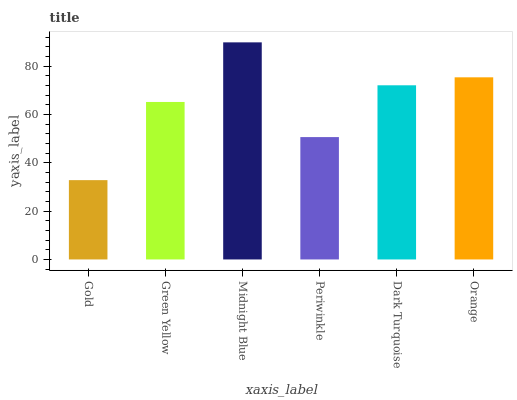Is Gold the minimum?
Answer yes or no. Yes. Is Midnight Blue the maximum?
Answer yes or no. Yes. Is Green Yellow the minimum?
Answer yes or no. No. Is Green Yellow the maximum?
Answer yes or no. No. Is Green Yellow greater than Gold?
Answer yes or no. Yes. Is Gold less than Green Yellow?
Answer yes or no. Yes. Is Gold greater than Green Yellow?
Answer yes or no. No. Is Green Yellow less than Gold?
Answer yes or no. No. Is Dark Turquoise the high median?
Answer yes or no. Yes. Is Green Yellow the low median?
Answer yes or no. Yes. Is Gold the high median?
Answer yes or no. No. Is Gold the low median?
Answer yes or no. No. 